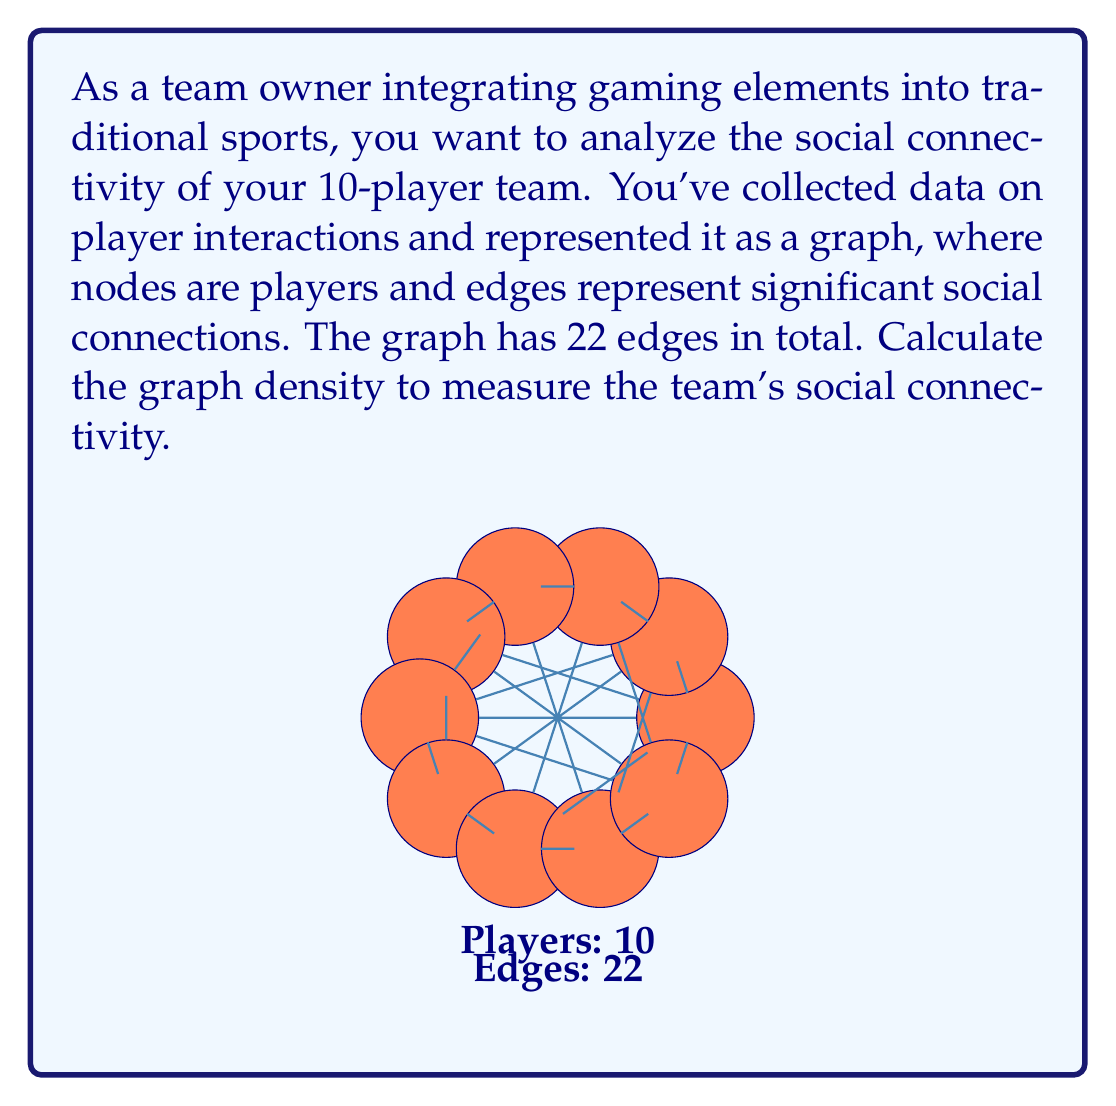Can you answer this question? To calculate the graph density, we'll follow these steps:

1) The graph density for an undirected graph is defined as:

   $$D = \frac{2|E|}{|V|(|V|-1)}$$

   where $|E|$ is the number of edges and $|V|$ is the number of vertices (nodes).

2) In this case:
   $|V| = 10$ (number of players)
   $|E| = 22$ (number of edges)

3) Substituting these values into the formula:

   $$D = \frac{2 \cdot 22}{10(10-1)} = \frac{44}{10 \cdot 9} = \frac{44}{90}$$

4) Simplifying:
   
   $$D = \frac{22}{45} \approx 0.4889$$

5) The density ranges from 0 to 1, where 0 indicates no connections and 1 indicates a complete graph (every node connected to every other node).

6) A density of approximately 0.4889 suggests a moderately well-connected team, with nearly half of all possible connections present.
Answer: $\frac{22}{45}$ or approximately 0.4889 